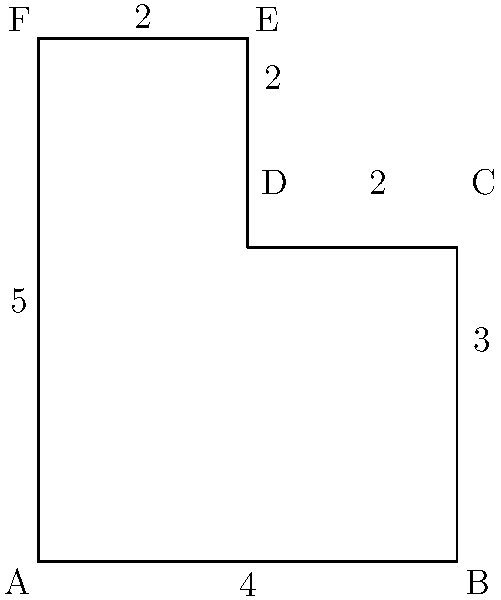Calculate the perimeter of the given shape. All measurements are in centimeters. To calculate the perimeter of this complex shape, we need to sum up the lengths of all its sides. Let's break it down step by step:

1. Bottom side (AB): 4 cm
2. Right side (BC): 3 cm
3. Upper right vertical side (CD): 2 cm
4. Upper right horizontal side (DE): 2 cm
5. Top side (EF): 2 cm
6. Left side (FA): 5 cm

Now, let's add all these lengths:

$$\text{Perimeter} = AB + BC + CD + DE + EF + FA$$
$$\text{Perimeter} = 4 + 3 + 2 + 2 + 2 + 5$$
$$\text{Perimeter} = 18 \text{ cm}$$

Therefore, the perimeter of the given shape is 18 cm.
Answer: 18 cm 